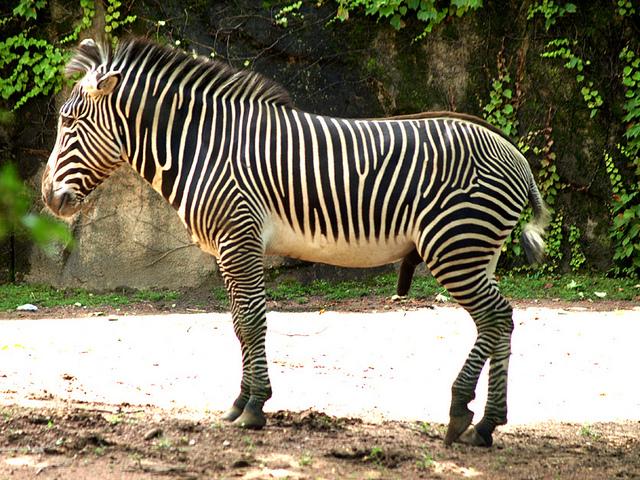Is one of the zebras grazing?
Keep it brief. No. What animal is this?
Concise answer only. Zebra. How many zebras are in the picture?
Quick response, please. 1. What direction are the zebra's stripes?
Short answer required. Vertical. 